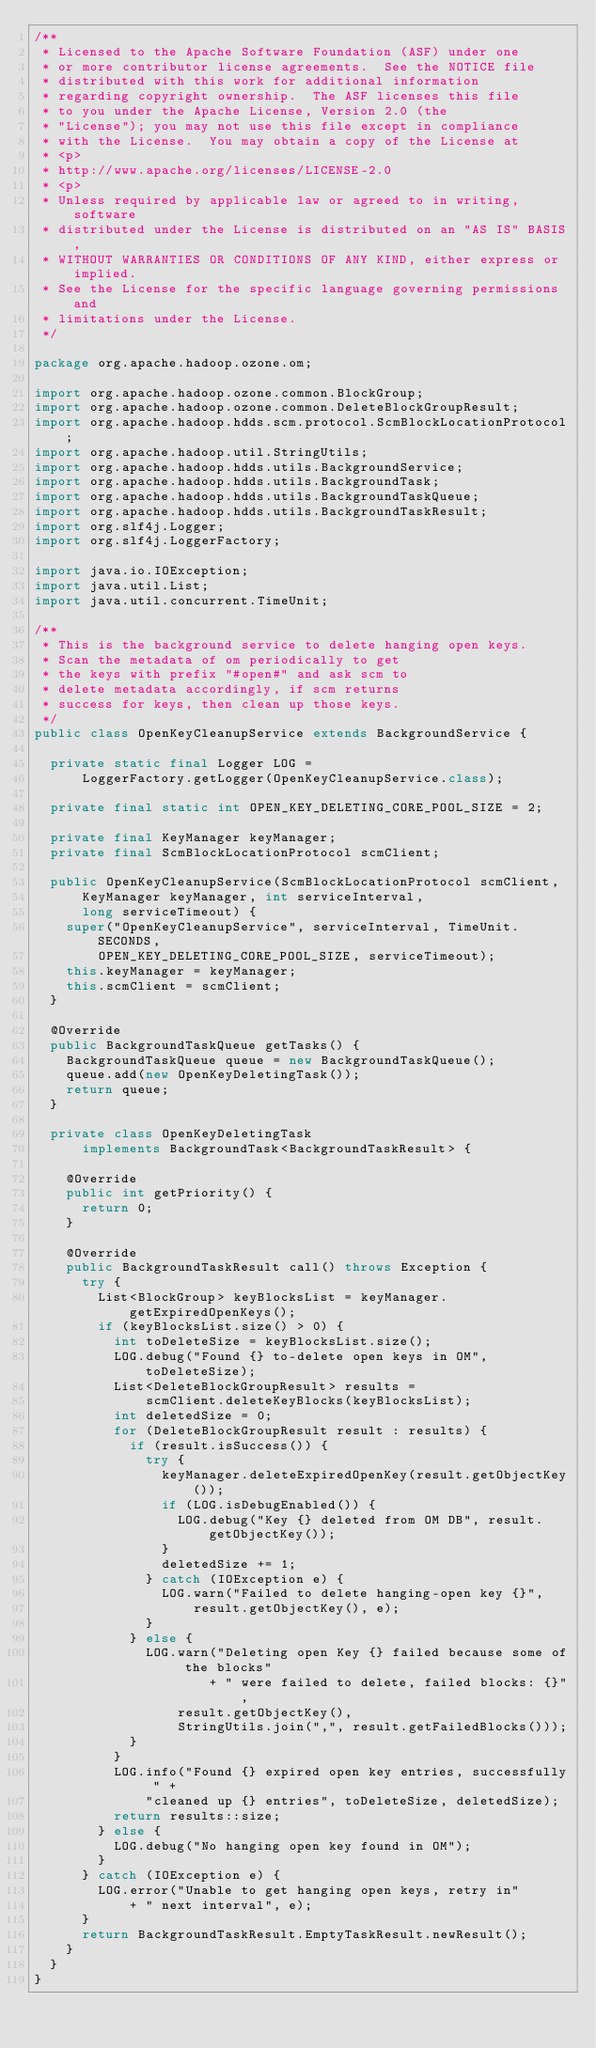Convert code to text. <code><loc_0><loc_0><loc_500><loc_500><_Java_>/**
 * Licensed to the Apache Software Foundation (ASF) under one
 * or more contributor license agreements.  See the NOTICE file
 * distributed with this work for additional information
 * regarding copyright ownership.  The ASF licenses this file
 * to you under the Apache License, Version 2.0 (the
 * "License"); you may not use this file except in compliance
 * with the License.  You may obtain a copy of the License at
 * <p>
 * http://www.apache.org/licenses/LICENSE-2.0
 * <p>
 * Unless required by applicable law or agreed to in writing, software
 * distributed under the License is distributed on an "AS IS" BASIS,
 * WITHOUT WARRANTIES OR CONDITIONS OF ANY KIND, either express or implied.
 * See the License for the specific language governing permissions and
 * limitations under the License.
 */

package org.apache.hadoop.ozone.om;

import org.apache.hadoop.ozone.common.BlockGroup;
import org.apache.hadoop.ozone.common.DeleteBlockGroupResult;
import org.apache.hadoop.hdds.scm.protocol.ScmBlockLocationProtocol;
import org.apache.hadoop.util.StringUtils;
import org.apache.hadoop.hdds.utils.BackgroundService;
import org.apache.hadoop.hdds.utils.BackgroundTask;
import org.apache.hadoop.hdds.utils.BackgroundTaskQueue;
import org.apache.hadoop.hdds.utils.BackgroundTaskResult;
import org.slf4j.Logger;
import org.slf4j.LoggerFactory;

import java.io.IOException;
import java.util.List;
import java.util.concurrent.TimeUnit;

/**
 * This is the background service to delete hanging open keys.
 * Scan the metadata of om periodically to get
 * the keys with prefix "#open#" and ask scm to
 * delete metadata accordingly, if scm returns
 * success for keys, then clean up those keys.
 */
public class OpenKeyCleanupService extends BackgroundService {

  private static final Logger LOG =
      LoggerFactory.getLogger(OpenKeyCleanupService.class);

  private final static int OPEN_KEY_DELETING_CORE_POOL_SIZE = 2;

  private final KeyManager keyManager;
  private final ScmBlockLocationProtocol scmClient;

  public OpenKeyCleanupService(ScmBlockLocationProtocol scmClient,
      KeyManager keyManager, int serviceInterval,
      long serviceTimeout) {
    super("OpenKeyCleanupService", serviceInterval, TimeUnit.SECONDS,
        OPEN_KEY_DELETING_CORE_POOL_SIZE, serviceTimeout);
    this.keyManager = keyManager;
    this.scmClient = scmClient;
  }

  @Override
  public BackgroundTaskQueue getTasks() {
    BackgroundTaskQueue queue = new BackgroundTaskQueue();
    queue.add(new OpenKeyDeletingTask());
    return queue;
  }

  private class OpenKeyDeletingTask
      implements BackgroundTask<BackgroundTaskResult> {

    @Override
    public int getPriority() {
      return 0;
    }

    @Override
    public BackgroundTaskResult call() throws Exception {
      try {
        List<BlockGroup> keyBlocksList = keyManager.getExpiredOpenKeys();
        if (keyBlocksList.size() > 0) {
          int toDeleteSize = keyBlocksList.size();
          LOG.debug("Found {} to-delete open keys in OM", toDeleteSize);
          List<DeleteBlockGroupResult> results =
              scmClient.deleteKeyBlocks(keyBlocksList);
          int deletedSize = 0;
          for (DeleteBlockGroupResult result : results) {
            if (result.isSuccess()) {
              try {
                keyManager.deleteExpiredOpenKey(result.getObjectKey());
                if (LOG.isDebugEnabled()) {
                  LOG.debug("Key {} deleted from OM DB", result.getObjectKey());
                }
                deletedSize += 1;
              } catch (IOException e) {
                LOG.warn("Failed to delete hanging-open key {}",
                    result.getObjectKey(), e);
              }
            } else {
              LOG.warn("Deleting open Key {} failed because some of the blocks"
                      + " were failed to delete, failed blocks: {}",
                  result.getObjectKey(),
                  StringUtils.join(",", result.getFailedBlocks()));
            }
          }
          LOG.info("Found {} expired open key entries, successfully " +
              "cleaned up {} entries", toDeleteSize, deletedSize);
          return results::size;
        } else {
          LOG.debug("No hanging open key found in OM");
        }
      } catch (IOException e) {
        LOG.error("Unable to get hanging open keys, retry in"
            + " next interval", e);
      }
      return BackgroundTaskResult.EmptyTaskResult.newResult();
    }
  }
}
</code> 